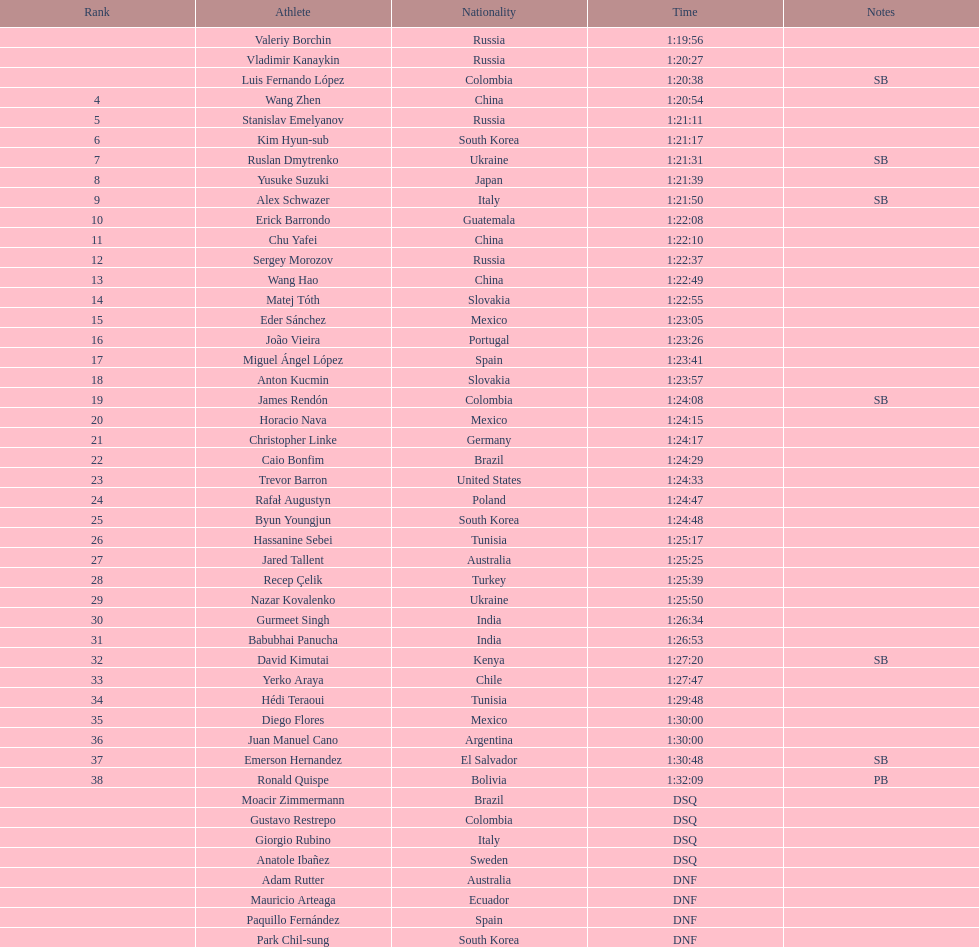Wang zhen and wang hao were both from which country? China. 